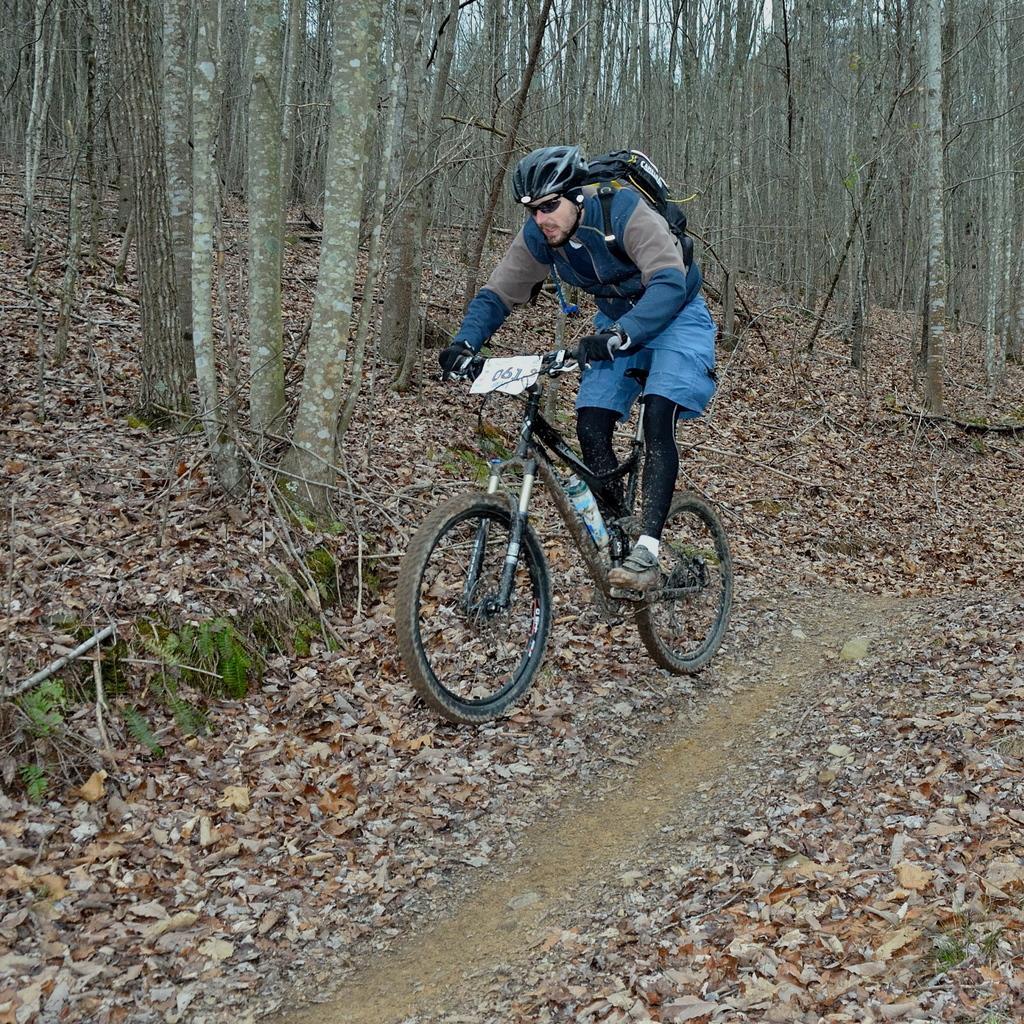How would you summarize this image in a sentence or two? Here in this picture we can see a person riding bicycle on the ground over there and we can see he is wearing gloves, goggles and helmet on him and carrying a bag with him and we can see trees present all over there and we can also see dry leaves on the ground over there. 